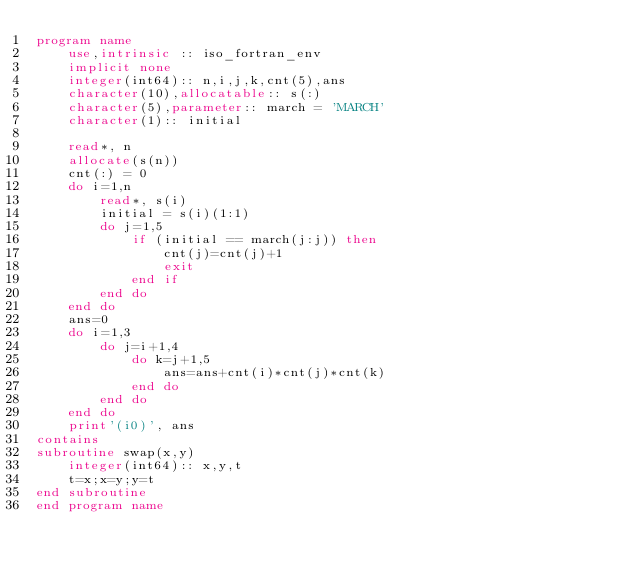<code> <loc_0><loc_0><loc_500><loc_500><_FORTRAN_>program name
    use,intrinsic :: iso_fortran_env
    implicit none
    integer(int64):: n,i,j,k,cnt(5),ans
    character(10),allocatable:: s(:)
    character(5),parameter:: march = 'MARCH'
    character(1):: initial

    read*, n
    allocate(s(n))
    cnt(:) = 0
    do i=1,n
        read*, s(i)
        initial = s(i)(1:1)
        do j=1,5
            if (initial == march(j:j)) then
                cnt(j)=cnt(j)+1
                exit
            end if
        end do
    end do
    ans=0
    do i=1,3
        do j=i+1,4
            do k=j+1,5
                ans=ans+cnt(i)*cnt(j)*cnt(k)
            end do
        end do
    end do
    print'(i0)', ans
contains
subroutine swap(x,y)
    integer(int64):: x,y,t
    t=x;x=y;y=t
end subroutine
end program name</code> 